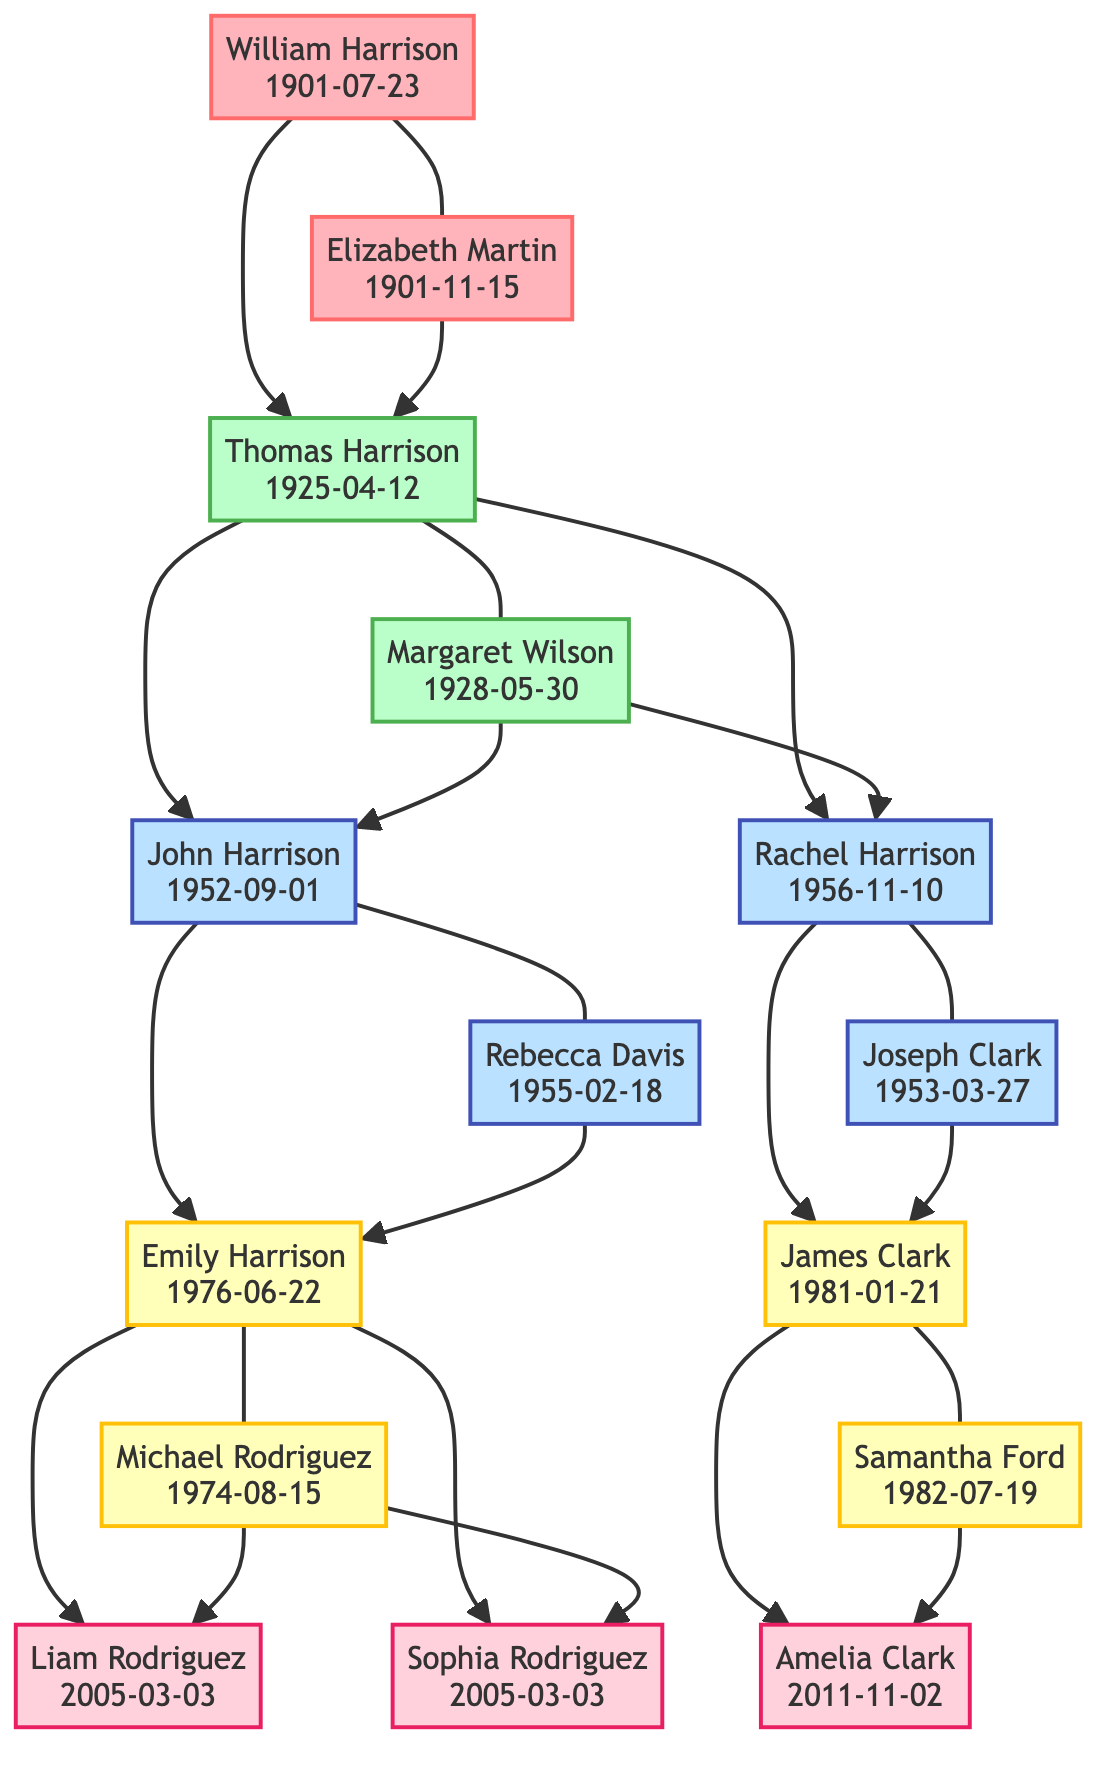What is the birthdate of Thomas Harrison? The diagram shows the node for Thomas Harrison indicating his birthdate directly below his name as "1925-04-12."
Answer: 1925-04-12 Who are the children of Thomas Harrison and Margaret Wilson? By reviewing the connections from Thomas Harrison, the diagram shows lines leading to two nodes: John Harrison and Rachel Harrison. These represent their children.
Answer: John Harrison, Rachel Harrison How many individuals are in the fifth generation? The diagram displays three nodes in the fifth generation: Liam Rodriguez, Sophia Rodriguez, and Amelia Clark. Therefore, counting these nodes gives the total number of individuals in this generation.
Answer: 3 Which individual is the spouse of Emily Harrison? By following the connection from Emily Harrison, the diagram indicates a line leading to Michael Rodriguez, who is represented as her spouse.
Answer: Michael Rodriguez What year was Rachel Harrison born? Observing the node for Rachel Harrison in the diagram shows her birthdate as "1956-11-10" directly beneath her name.
Answer: 1956-11-10 Who is the parent of Amelia Clark? The parentage can be traced from the diagram; Amelia Clark is connected to James Clark and Samantha Ford, which indicates they are her parents.
Answer: James Clark, Samantha Ford How many generations are represented in this family tree? The diagram indicates that there are five distinct generational classes illustrated, each marked with different colors corresponding to different generations.
Answer: 5 What is the birthdate of the earliest generation individual? The diagram shows the earliest individuals in generation one, William Harrison and Elizabeth Martin, both born in 1901, with William's specific birth date being "1901-07-23," which is the earliest.
Answer: 1901-07-23 Which two individuals were born on the same day? Referring to the fifth generation, both Liam Rodriguez and Sophia Rodriguez are shown with the birthdate "2005-03-03," indicating they share the same birthday.
Answer: Liam Rodriguez, Sophia Rodriguez 